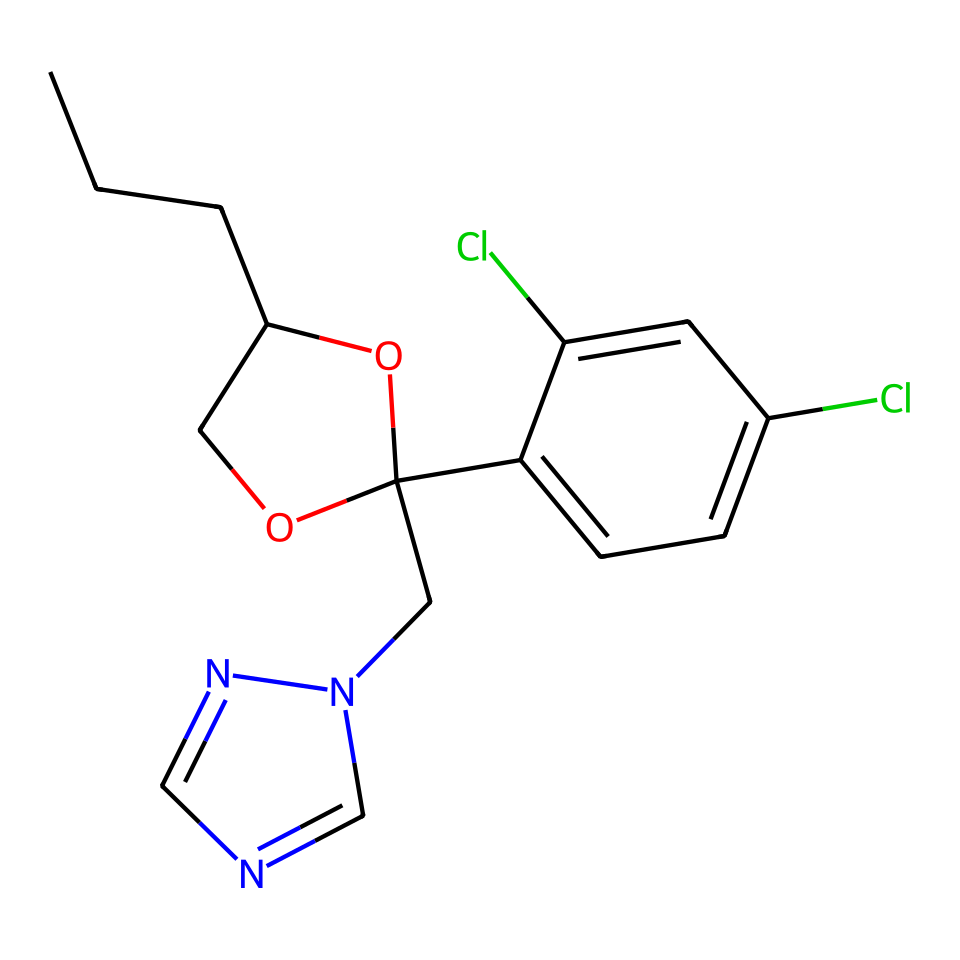How many carbon atoms are present in the compound? By analyzing the SMILES representation, we can count the 'C' characters as well as those forming part of branches and rings. The main carbon chain and the aromatic components show a total of 15 carbon atoms.
Answer: 15 What is the function of the chlorine atoms in the molecule? The chlorine atoms are typically used for their antimicrobial properties in the structure of fungicides. They play a role in increasing the efficacy and stability of the compound against fungal activity.
Answer: antimicrobial What type of functional groups are present in this structure? The structure includes a hydroxy group (–OH), shown as 'O' in the ring, and a triazole ring which is characteristic of triazole fungicides. These functional groups contribute to the biological activity of the compound.
Answer: hydroxy and triazole How many nitrogen atoms are in the compound? Looking at the SMILES, we can identify two nitrogen atoms represented by the 'n' characters in the triazole component, indicating that the compound contains two nitrogen atoms.
Answer: 2 What is the primary role of propiconazole in building materials? Propiconazole is primarily used as a fungicide to prevent the growth of mold and mildew in building materials. It is effective against a wide range of fungi, thereby protecting structural integrity.
Answer: fungicide What is the significance of the oxygen atom in the molecule? The oxygen atom is part of the hydroxy group and contributes to the water solubility of the compound, facilitating its distribution in building materials and overall efficacy as a fungicide.
Answer: water solubility What does the presence of the triazole ring indicate about this compound? The presence of the triazole ring indicates that the compound functions as a triazole fungicide, which inhibits fungal growth by disrupting their ergosterol synthesis, a critical component of fungal cell membranes.
Answer: triazole fungicide 